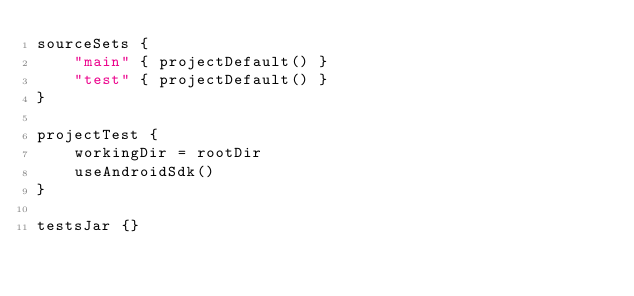<code> <loc_0><loc_0><loc_500><loc_500><_Kotlin_>sourceSets {
    "main" { projectDefault() }
    "test" { projectDefault() }
}

projectTest {
    workingDir = rootDir
    useAndroidSdk()
}

testsJar {}</code> 